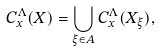Convert formula to latex. <formula><loc_0><loc_0><loc_500><loc_500>C _ { x } ^ { \Lambda } ( X ) = \bigcup _ { \xi \in A } C _ { x } ^ { \Lambda } ( X _ { \xi } ) ,</formula> 